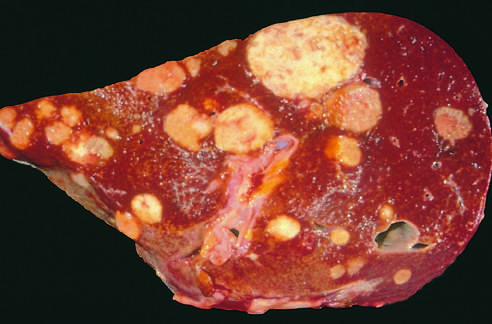how is a liver studded?
Answer the question using a single word or phrase. With metastatic cancer 